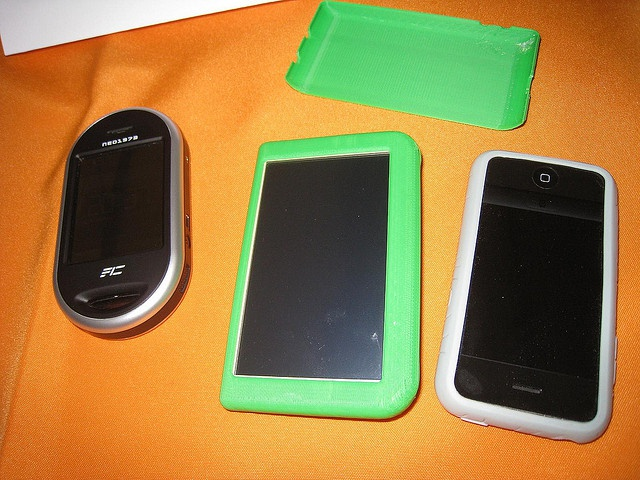Describe the objects in this image and their specific colors. I can see cell phone in darkgray, black, lightgreen, and gray tones, cell phone in darkgray, black, lightgray, and gray tones, and cell phone in darkgray, black, maroon, and gray tones in this image. 